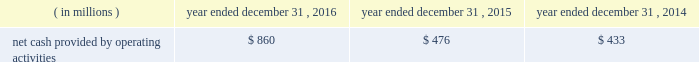Special purpose entity ( 201cspe 201d ) .
The spe obtained a term loan and revolving loan commitment from a third party lender , secured by liens on the assets of the spe , to finance the purchase of the accounts receivable , which included a $ 275 million term loan and a $ 25 million revolving loan commitment .
The revolving loan commitment may be increased by an additional $ 35 million as amounts are repaid under the term loan .
Quintilesims has guaranteed the performance of the obligations of existing and future subsidiaries that sell and service the accounts receivable under the receivables financing facility .
The assets of the spe are not available to satisfy any of our obligations or any obligations of our subsidiaries .
As of december 31 , 2016 , the full $ 25 million of revolving loan commitment was available under the receivables financing facility .
We used the proceeds from the term loan under the receivables financing facility to repay in full the amount outstanding on the then outstanding revolving credit facility under its then outstanding senior secured credit agreement ( $ 150 million ) , to repay $ 25 million of the then outstanding term loan b-3 , to pay related fees and expenses and the remainder was used for general working capital purposes .
Restrictive covenants our debt agreements provide for certain covenants and events of default customary for similar instruments , including a covenant not to exceed a specified ratio of consolidated senior secured net indebtedness to consolidated ebitda , as defined in the senior secured credit facility and a covenant to maintain a specified minimum interest coverage ratio .
If an event of default occurs under any of the company 2019s or the company 2019s subsidiaries 2019 financing arrangements , the creditors under such financing arrangements will be entitled to take various actions , including the acceleration of amounts due under such arrangements , and in the case of the lenders under the revolving credit facility and new term loans , other actions permitted to be taken by a secured creditor .
Our long-term debt arrangements contain usual and customary restrictive covenants that , among other things , place limitations on our ability to declare dividends .
For additional information regarding these restrictive covenants , see part ii , item 5 201cmarket for registrant 2019s common equity , related stockholder matters and issuer purchases of equity securities 2014dividend policy 201d and note 11 to our audited consolidated financial statements included elsewhere in this annual report on form 10-k .
At december 31 , 2016 , the company was in compliance with the financial covenants under the company 2019s financing arrangements .
Years ended december 31 , 2016 , 2015 and 2014 cash flow from operating activities .
2016 compared to 2015 cash provided by operating activities increased $ 384 million in 2016 as compared to 2015 .
The increase in cash provided by operating activities reflects the increase in net income as adjusted for non-cash items necessary to reconcile net income to cash provided by operating activities .
Also contributing to the increase were lower payments for income taxes ( $ 15 million ) , and lower cash used in days sales outstanding ( 201cdso 201d ) and accounts payable and accrued expenses .
The lower cash used in dso reflects a two-day increase in dso in 2016 compared to a seven-day increase in dso in 2015 .
Dso can shift significantly at each reporting period depending on the timing of cash receipts under contractual payment terms relative to the recognition of revenue over a project lifecycle. .
What is the percent increase in net cash provided by operating activities from 2015 to 2016? 
Computations: (384 / 476)
Answer: 0.80672. 